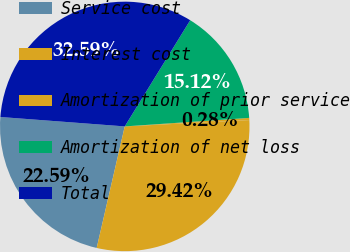<chart> <loc_0><loc_0><loc_500><loc_500><pie_chart><fcel>Service cost<fcel>Interest cost<fcel>Amortization of prior service<fcel>Amortization of net loss<fcel>Total<nl><fcel>22.59%<fcel>29.42%<fcel>0.28%<fcel>15.12%<fcel>32.59%<nl></chart> 